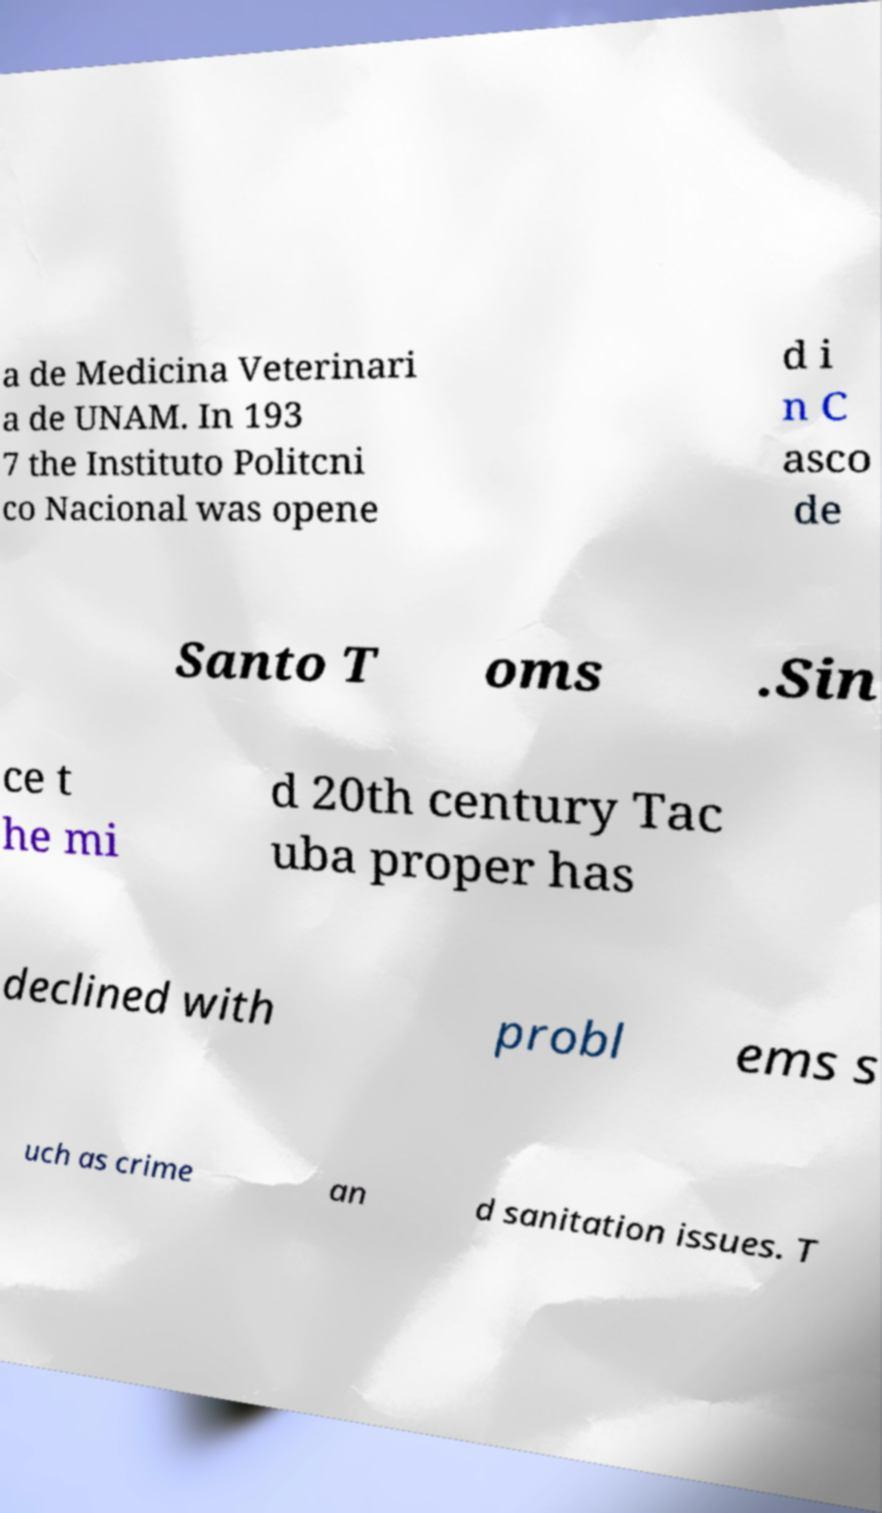Please read and relay the text visible in this image. What does it say? a de Medicina Veterinari a de UNAM. In 193 7 the Instituto Politcni co Nacional was opene d i n C asco de Santo T oms .Sin ce t he mi d 20th century Tac uba proper has declined with probl ems s uch as crime an d sanitation issues. T 